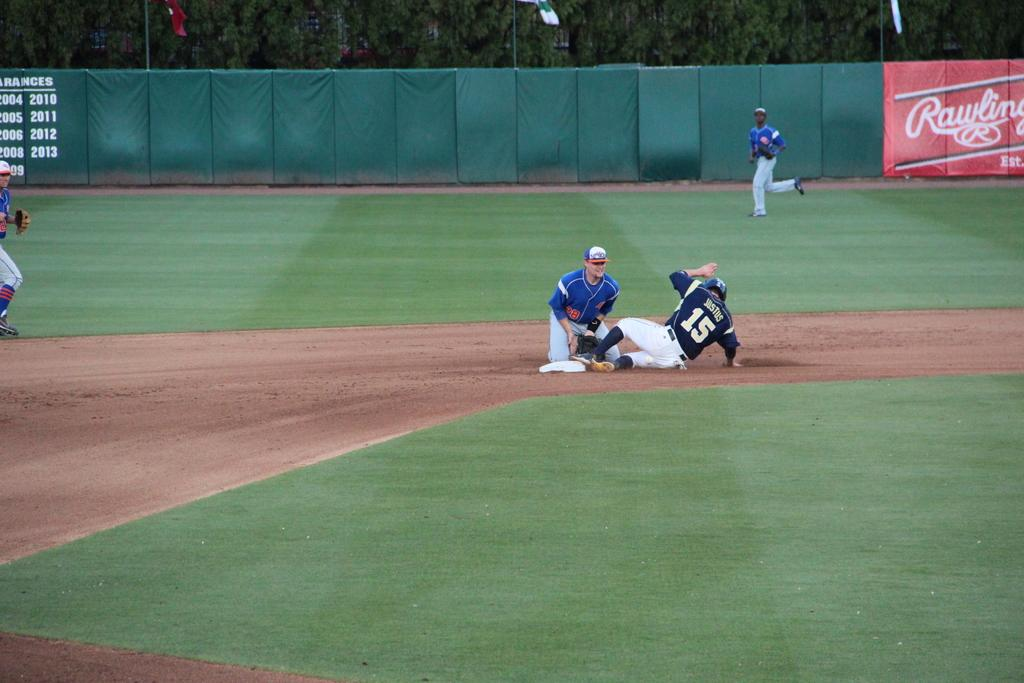What are the people in the image wearing? The people in the image are wearing jerseys. What type of surface is visible in the image? There is green grass in the image. What is the purpose of the fence in the image? The fence in the image serves as a boundary or barrier. What can be seen in the background of the image? There are trees in the image. What decorative or symbolic elements are present in the image? There are flags in the image. How many cars can be seen driving on the grass in the image? There are no cars visible in the image; it features people wearing jerseys, green grass, a fence, trees, and flags. What type of pig is present in the image? There is no pig present in the image. 